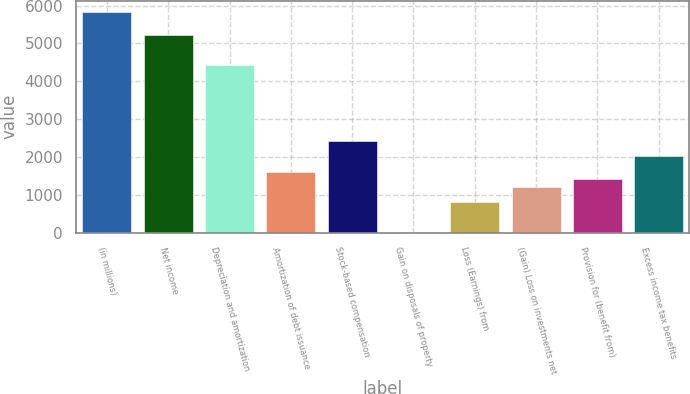Convert chart to OTSL. <chart><loc_0><loc_0><loc_500><loc_500><bar_chart><fcel>(in millions)<fcel>Net income<fcel>Depreciation and amortization<fcel>Amortization of debt issuance<fcel>Stock-based compensation<fcel>Gain on disposals of property<fcel>Loss (Earnings) from<fcel>(Gain) Loss on investments net<fcel>Provision for (benefit from)<fcel>Excess income tax benefits<nl><fcel>5838.7<fcel>5234.8<fcel>4429.6<fcel>1611.4<fcel>2416.6<fcel>1<fcel>806.2<fcel>1208.8<fcel>1410.1<fcel>2014<nl></chart> 